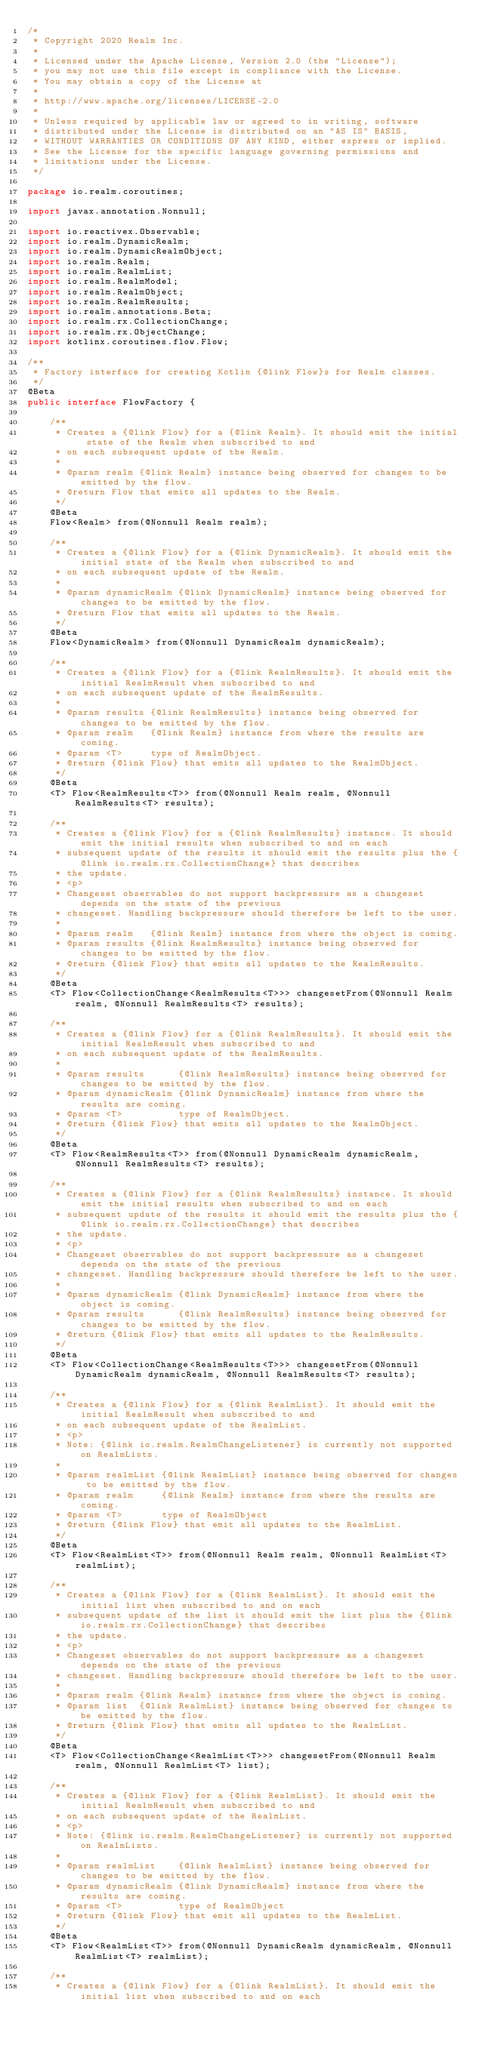Convert code to text. <code><loc_0><loc_0><loc_500><loc_500><_Java_>/*
 * Copyright 2020 Realm Inc.
 *
 * Licensed under the Apache License, Version 2.0 (the "License");
 * you may not use this file except in compliance with the License.
 * You may obtain a copy of the License at
 *
 * http://www.apache.org/licenses/LICENSE-2.0
 *
 * Unless required by applicable law or agreed to in writing, software
 * distributed under the License is distributed on an "AS IS" BASIS,
 * WITHOUT WARRANTIES OR CONDITIONS OF ANY KIND, either express or implied.
 * See the License for the specific language governing permissions and
 * limitations under the License.
 */

package io.realm.coroutines;

import javax.annotation.Nonnull;

import io.reactivex.Observable;
import io.realm.DynamicRealm;
import io.realm.DynamicRealmObject;
import io.realm.Realm;
import io.realm.RealmList;
import io.realm.RealmModel;
import io.realm.RealmObject;
import io.realm.RealmResults;
import io.realm.annotations.Beta;
import io.realm.rx.CollectionChange;
import io.realm.rx.ObjectChange;
import kotlinx.coroutines.flow.Flow;

/**
 * Factory interface for creating Kotlin {@link Flow}s for Realm classes.
 */
@Beta
public interface FlowFactory {

    /**
     * Creates a {@link Flow} for a {@link Realm}. It should emit the initial state of the Realm when subscribed to and
     * on each subsequent update of the Realm.
     *
     * @param realm {@link Realm} instance being observed for changes to be emitted by the flow.
     * @return Flow that emits all updates to the Realm.
     */
    @Beta
    Flow<Realm> from(@Nonnull Realm realm);

    /**
     * Creates a {@link Flow} for a {@link DynamicRealm}. It should emit the initial state of the Realm when subscribed to and
     * on each subsequent update of the Realm.
     *
     * @param dynamicRealm {@link DynamicRealm} instance being observed for changes to be emitted by the flow.
     * @return Flow that emits all updates to the Realm.
     */
    @Beta
    Flow<DynamicRealm> from(@Nonnull DynamicRealm dynamicRealm);

    /**
     * Creates a {@link Flow} for a {@link RealmResults}. It should emit the initial RealmResult when subscribed to and
     * on each subsequent update of the RealmResults.
     *
     * @param results {@link RealmResults} instance being observed for changes to be emitted by the flow.
     * @param realm   {@link Realm} instance from where the results are coming.
     * @param <T>     type of RealmObject.
     * @return {@link Flow} that emits all updates to the RealmObject.
     */
    @Beta
    <T> Flow<RealmResults<T>> from(@Nonnull Realm realm, @Nonnull RealmResults<T> results);

    /**
     * Creates a {@link Flow} for a {@link RealmResults} instance. It should emit the initial results when subscribed to and on each
     * subsequent update of the results it should emit the results plus the {@link io.realm.rx.CollectionChange} that describes
     * the update.
     * <p>
     * Changeset observables do not support backpressure as a changeset depends on the state of the previous
     * changeset. Handling backpressure should therefore be left to the user.
     *
     * @param realm   {@link Realm} instance from where the object is coming.
     * @param results {@link RealmResults} instance being observed for changes to be emitted by the flow.
     * @return {@link Flow} that emits all updates to the RealmResults.
     */
    @Beta
    <T> Flow<CollectionChange<RealmResults<T>>> changesetFrom(@Nonnull Realm realm, @Nonnull RealmResults<T> results);

    /**
     * Creates a {@link Flow} for a {@link RealmResults}. It should emit the initial RealmResult when subscribed to and
     * on each subsequent update of the RealmResults.
     *
     * @param results      {@link RealmResults} instance being observed for changes to be emitted by the flow.
     * @param dynamicRealm {@link DynamicRealm} instance from where the results are coming.
     * @param <T>          type of RealmObject.
     * @return {@link Flow} that emits all updates to the RealmObject.
     */
    @Beta
    <T> Flow<RealmResults<T>> from(@Nonnull DynamicRealm dynamicRealm, @Nonnull RealmResults<T> results);

    /**
     * Creates a {@link Flow} for a {@link RealmResults} instance. It should emit the initial results when subscribed to and on each
     * subsequent update of the results it should emit the results plus the {@link io.realm.rx.CollectionChange} that describes
     * the update.
     * <p>
     * Changeset observables do not support backpressure as a changeset depends on the state of the previous
     * changeset. Handling backpressure should therefore be left to the user.
     *
     * @param dynamicRealm {@link DynamicRealm} instance from where the object is coming.
     * @param results      {@link RealmResults} instance being observed for changes to be emitted by the flow.
     * @return {@link Flow} that emits all updates to the RealmResults.
     */
    @Beta
    <T> Flow<CollectionChange<RealmResults<T>>> changesetFrom(@Nonnull DynamicRealm dynamicRealm, @Nonnull RealmResults<T> results);

    /**
     * Creates a {@link Flow} for a {@link RealmList}. It should emit the initial RealmResult when subscribed to and
     * on each subsequent update of the RealmList.
     * <p>
     * Note: {@link io.realm.RealmChangeListener} is currently not supported on RealmLists.
     *
     * @param realmList {@link RealmList} instance being observed for changes to be emitted by the flow.
     * @param realm     {@link Realm} instance from where the results are coming.
     * @param <T>       type of RealmObject
     * @return {@link Flow} that emit all updates to the RealmList.
     */
    @Beta
    <T> Flow<RealmList<T>> from(@Nonnull Realm realm, @Nonnull RealmList<T> realmList);

    /**
     * Creates a {@link Flow} for a {@link RealmList}. It should emit the initial list when subscribed to and on each
     * subsequent update of the list it should emit the list plus the {@link io.realm.rx.CollectionChange} that describes
     * the update.
     * <p>
     * Changeset observables do not support backpressure as a changeset depends on the state of the previous
     * changeset. Handling backpressure should therefore be left to the user.
     *
     * @param realm {@link Realm} instance from where the object is coming.
     * @param list  {@link RealmList} instance being observed for changes to be emitted by the flow.
     * @return {@link Flow} that emits all updates to the RealmList.
     */
    @Beta
    <T> Flow<CollectionChange<RealmList<T>>> changesetFrom(@Nonnull Realm realm, @Nonnull RealmList<T> list);

    /**
     * Creates a {@link Flow} for a {@link RealmList}. It should emit the initial RealmResult when subscribed to and
     * on each subsequent update of the RealmList.
     * <p>
     * Note: {@link io.realm.RealmChangeListener} is currently not supported on RealmLists.
     *
     * @param realmList    {@link RealmList} instance being observed for changes to be emitted by the flow.
     * @param dynamicRealm {@link DynamicRealm} instance from where the results are coming.
     * @param <T>          type of RealmObject
     * @return {@link Flow} that emit all updates to the RealmList.
     */
    @Beta
    <T> Flow<RealmList<T>> from(@Nonnull DynamicRealm dynamicRealm, @Nonnull RealmList<T> realmList);

    /**
     * Creates a {@link Flow} for a {@link RealmList}. It should emit the initial list when subscribed to and on each</code> 